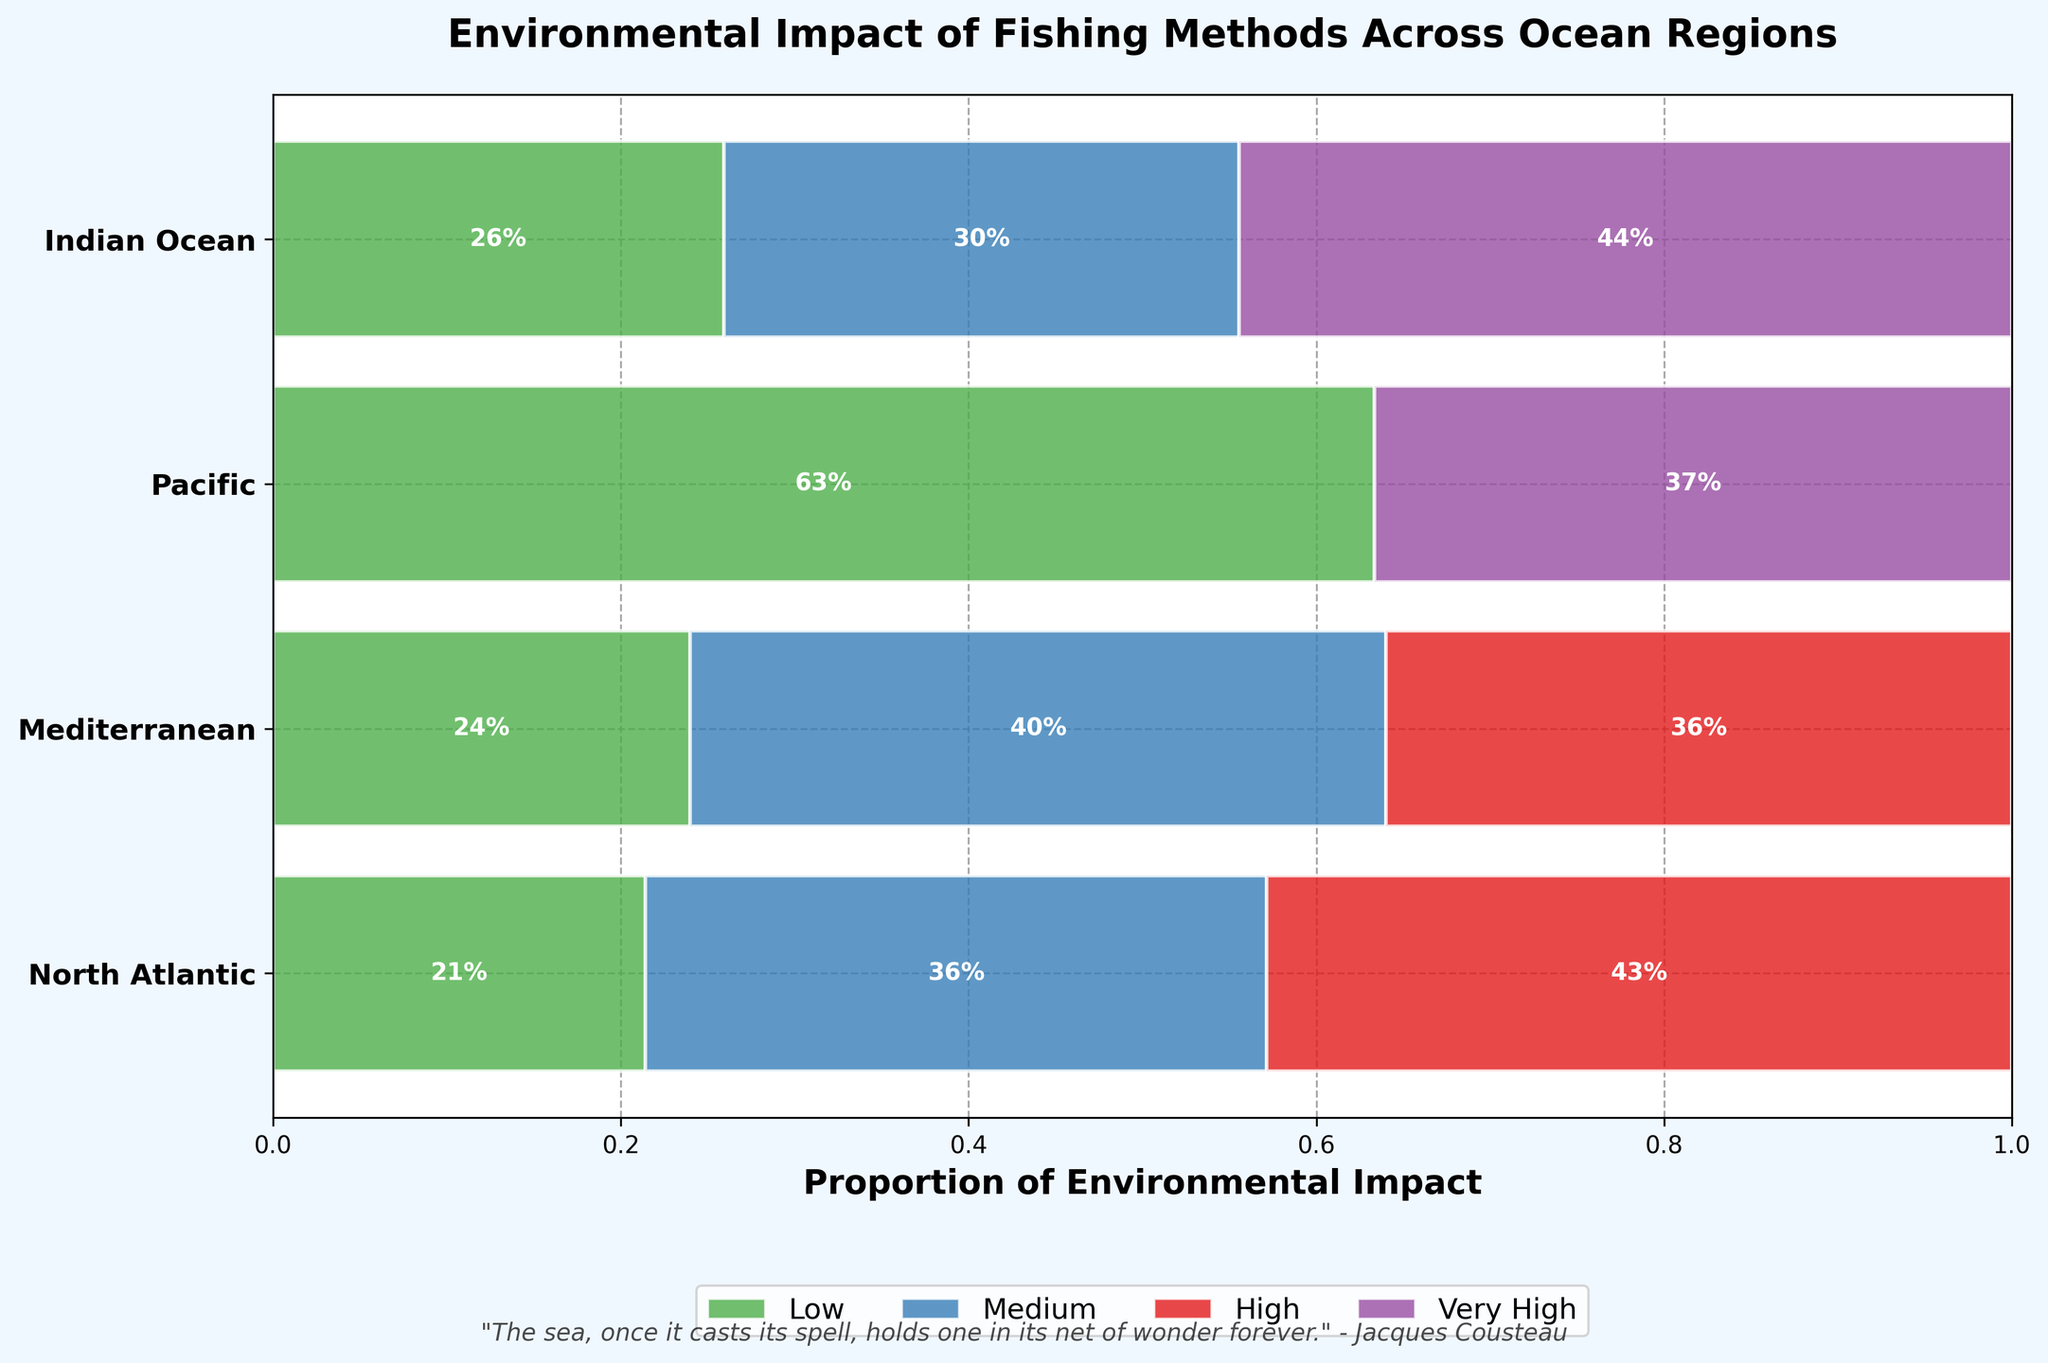What is the title of the figure? The title of the figure is usually located at the top of the plot, providing a brief description of what the figure is about. In this case, it should be directly readable.
Answer: Environmental Impact of Fishing Methods Across Ocean Regions Which ocean region has the highest proportion of 'Very High' environmental impact? By examining the colors and proportions within each ocean region's section, the 'Very High' impact is represented by a specific color (purple). The tallest section of this color indicates the highest proportion.
Answer: Indian Ocean How does the environmental impact distribution in the North Atlantic region compare to the Mediterranean region? To compare the distributions, observe the proportions of each impact category (Low, Medium, High, Very High) in both regions. The North Atlantic has no 'Very High' impact, while the Mediterranean shows a balanced impact allocation across Medium, High, and Low.
Answer: The North Atlantic has more 'Low' and 'Medium' impacts; the Mediterranean has more 'Medium' and 'High' impacts What is the total proportion of 'Low' environmental impact across all ocean regions? To find the total proportion of 'Low' impact, sum the proportions of the 'Low' category (green) from each region. This requires adding the segments colored green from all the regions.
Answer: Approximately 56% Which ocean region has the least 'High' environmental impact? 'High' impacts are represented by red. By comparing the height of the red sections across various regions, the smallest red segment indicates the least 'High' impact.
Answer: North Atlantic What can be inferred about the Pacific region's fishing methods based on 'Low' environmental impact? The Pacific region has a significant proportion of 'Low' environmental impact (green color). This suggests that many of its fishing methods are less detrimental to the environment.
Answer: Pacific focuses on less impactful fishing methods In which ocean region is the 'Medium' environmental impact most prevalent? The 'Medium' impact is represented by blue. By comparing the blue segments across regions, the one with the largest blue section has the most prevalent 'Medium' impact.
Answer: North Atlantic How do the proportions of 'Very High' and 'High' impacts in the Pacific region compare? For the Pacific, compare the purple (Very High) and red (High) segments' sizes. The taller segment indicates a higher proportion.
Answer: 'Very High' is higher than 'High' in the Pacific Describe the environmental impact pattern in the Indian Ocean. By examining the proportions of each impact category, we can see that the Indian Ocean has significant 'Very High' (purple) impact, followed by moderate 'Medium' (blue) and 'Low' (green) impacts.
Answer: Predominantly 'Very High', followed by 'Medium' and 'Low' 